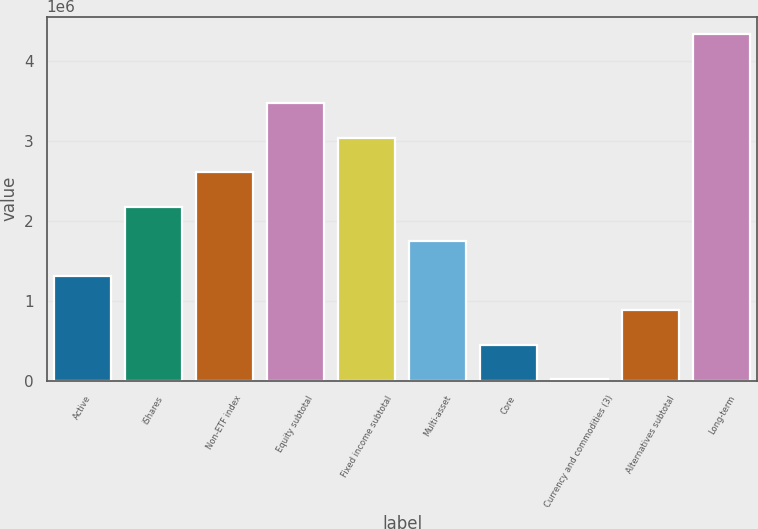<chart> <loc_0><loc_0><loc_500><loc_500><bar_chart><fcel>Active<fcel>iShares<fcel>Non-ETF index<fcel>Equity subtotal<fcel>Fixed income subtotal<fcel>Multi-asset<fcel>Core<fcel>Currency and commodities (3)<fcel>Alternatives subtotal<fcel>Long-term<nl><fcel>1.31642e+06<fcel>2.17854e+06<fcel>2.6096e+06<fcel>3.47172e+06<fcel>3.04066e+06<fcel>1.74748e+06<fcel>454295<fcel>23234<fcel>885355<fcel>4.33384e+06<nl></chart> 